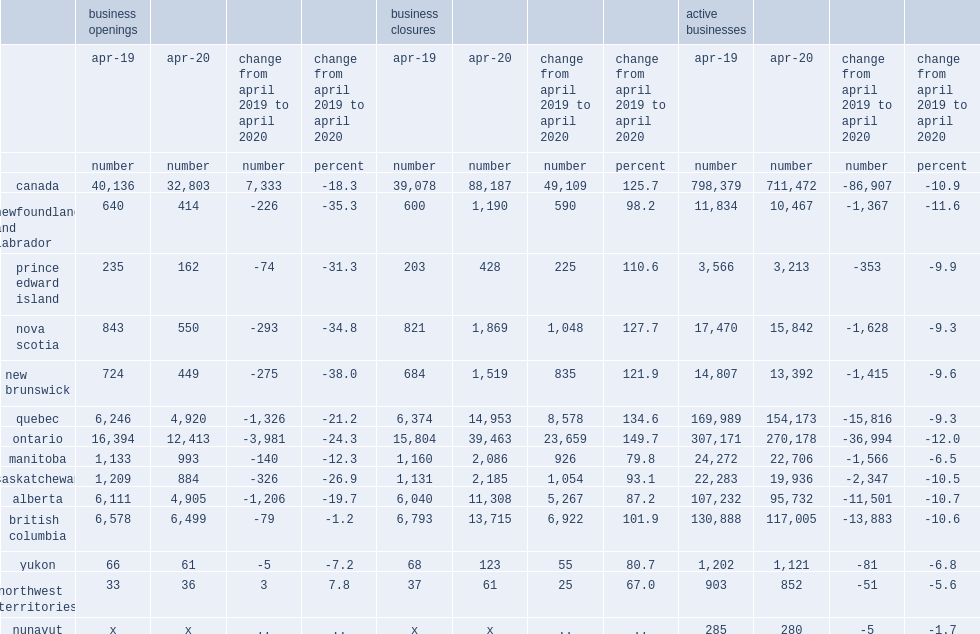What was the largest increases in percentage terms occurred in ontario? 149.7. What was the increases in percentage terms occurred in quebec? 134.6. What was the increases in percentage terms occurred in nova scotia? 127.7. 